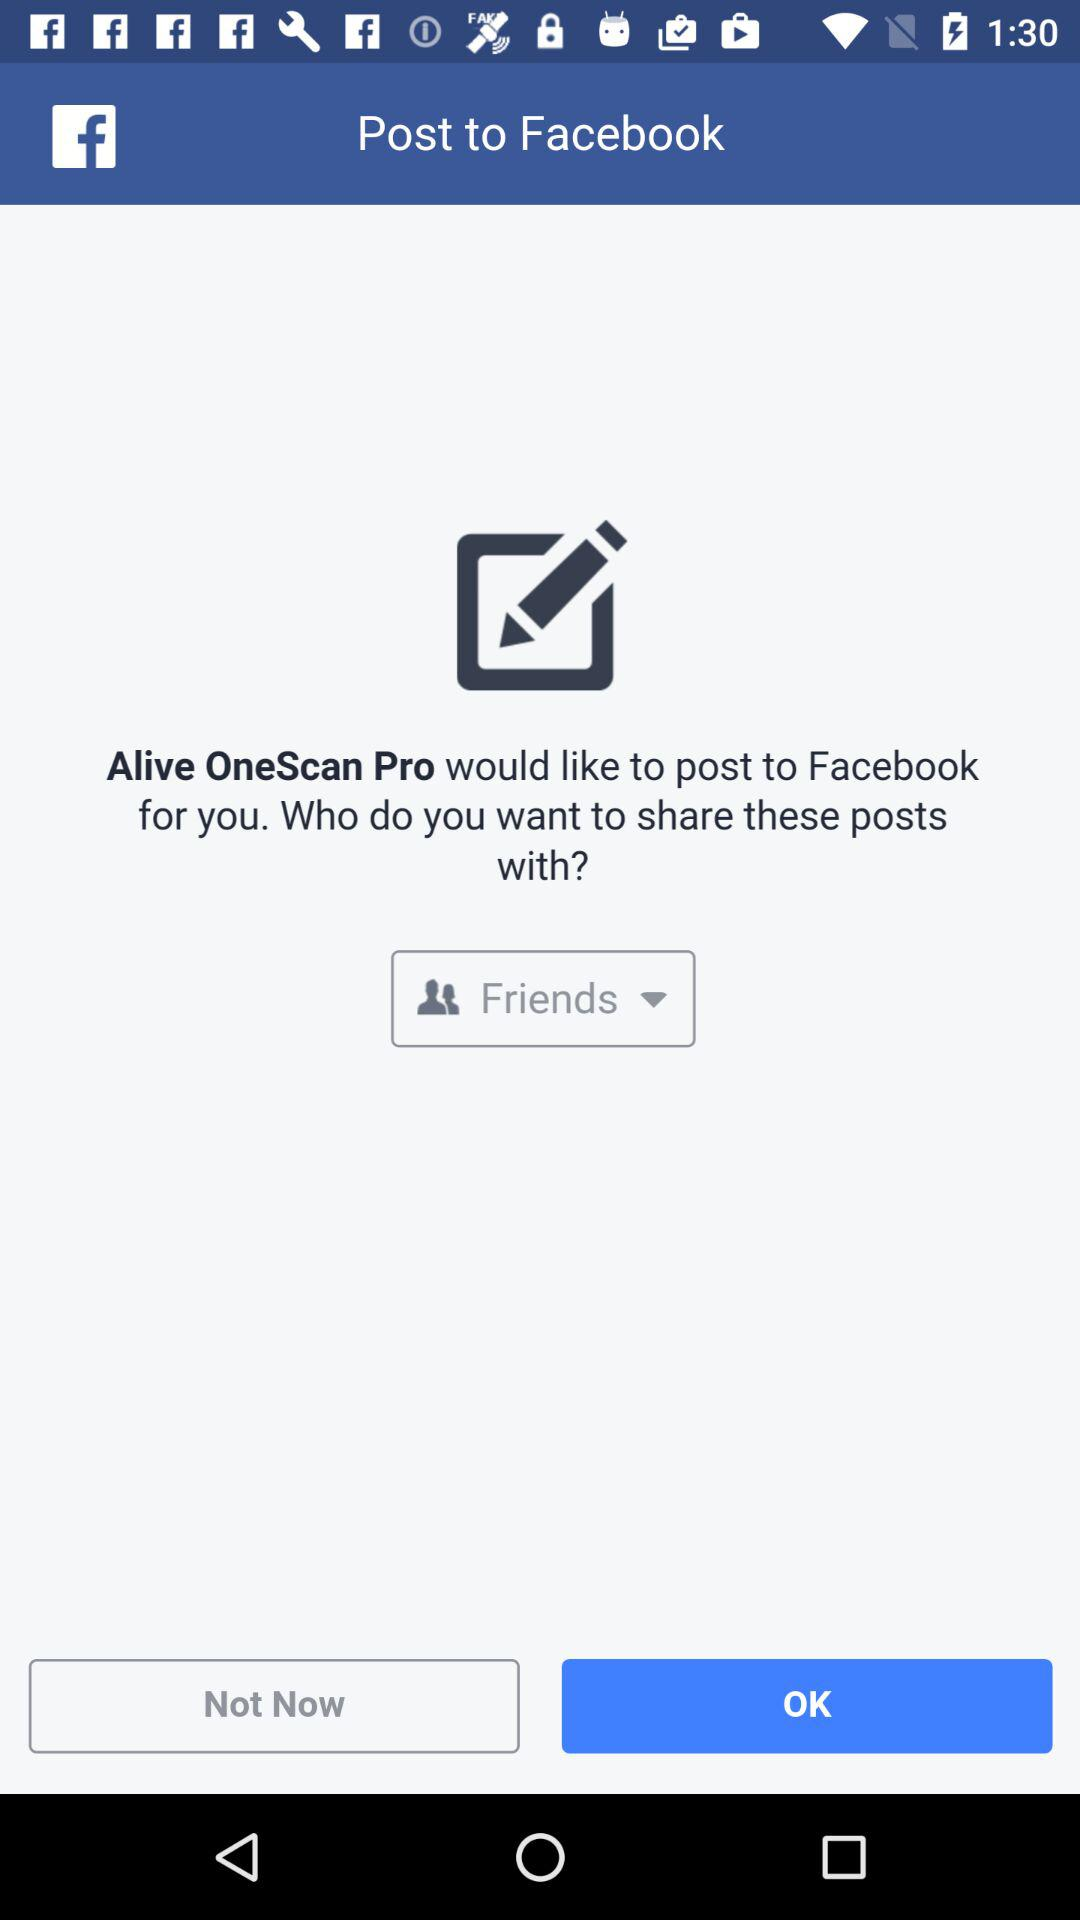Who is this application powered by?
When the provided information is insufficient, respond with <no answer>. <no answer> 